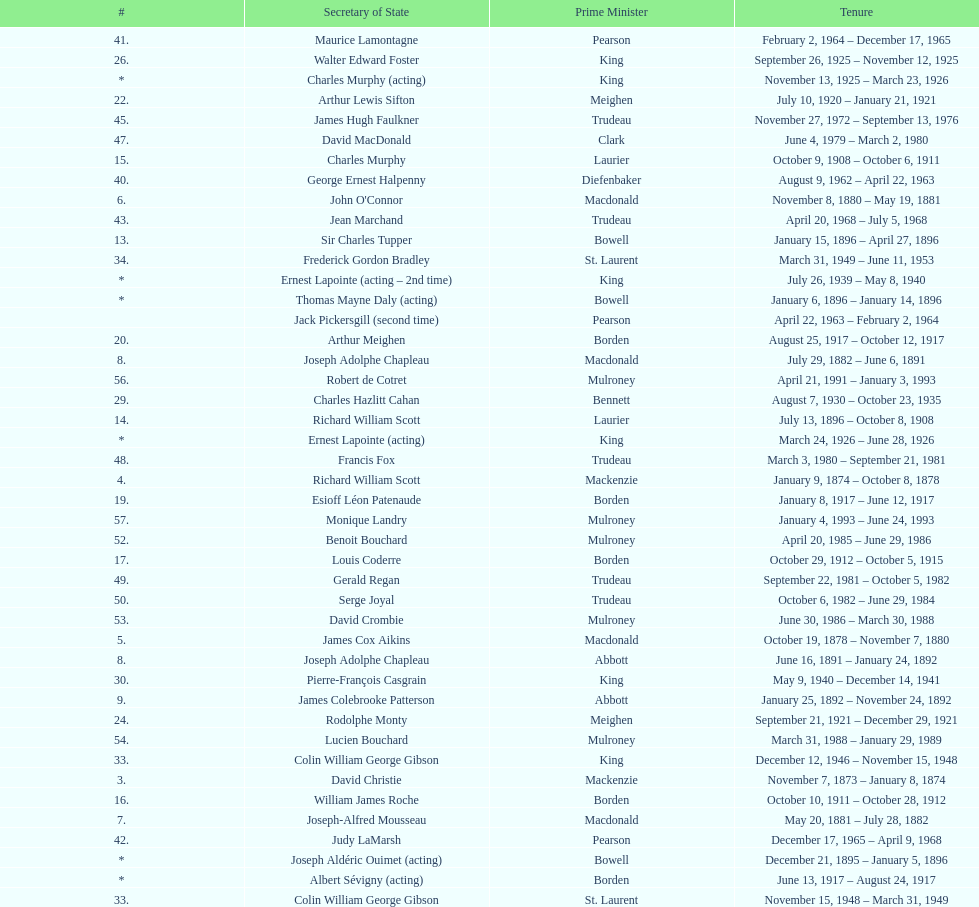How many secretaries of state had the last name bouchard? 2. 